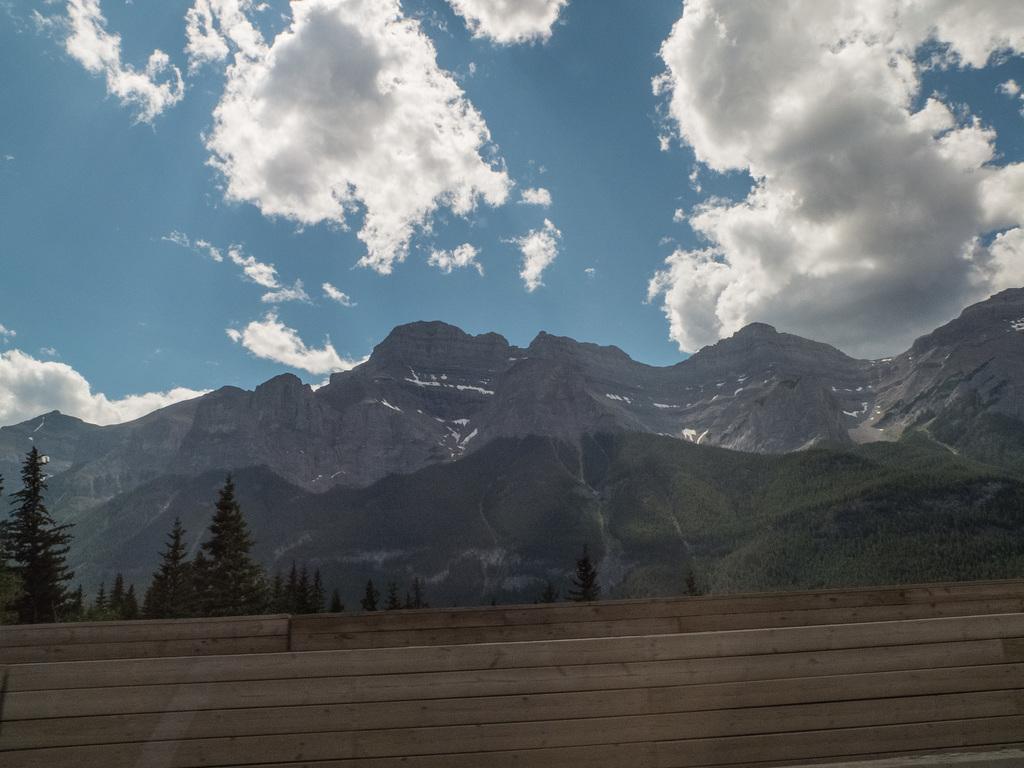How would you summarize this image in a sentence or two? This picture is taken outside of the city. In this image, we can see a wood wall, trees, plants, mountains. At the top, we can see a sky a bit cloudy. 